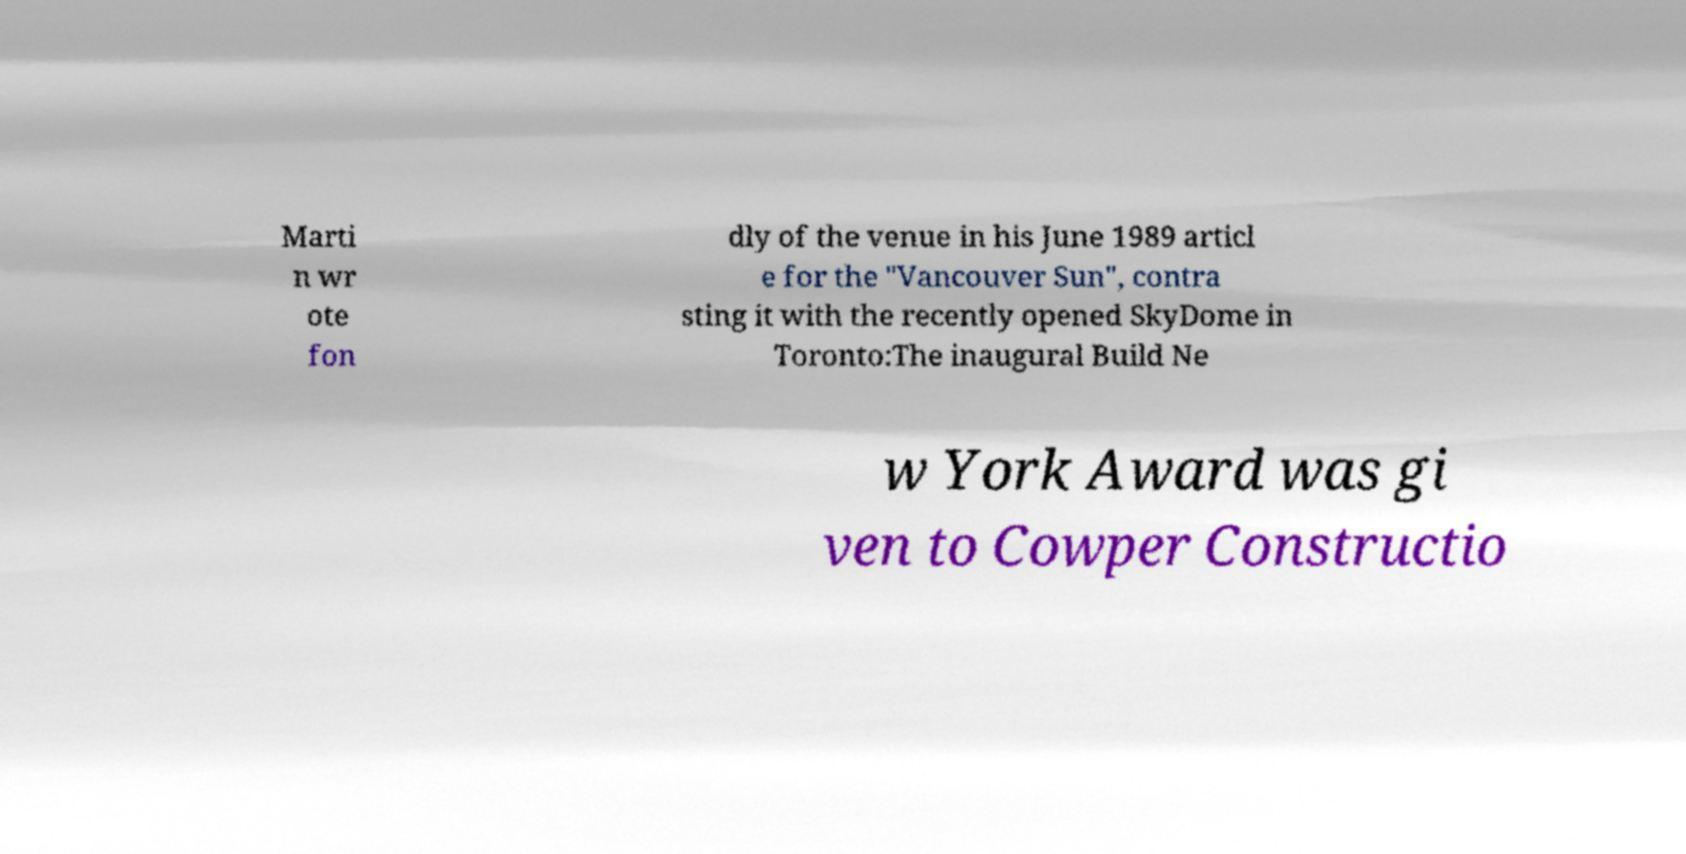Please read and relay the text visible in this image. What does it say? Marti n wr ote fon dly of the venue in his June 1989 articl e for the "Vancouver Sun", contra sting it with the recently opened SkyDome in Toronto:The inaugural Build Ne w York Award was gi ven to Cowper Constructio 